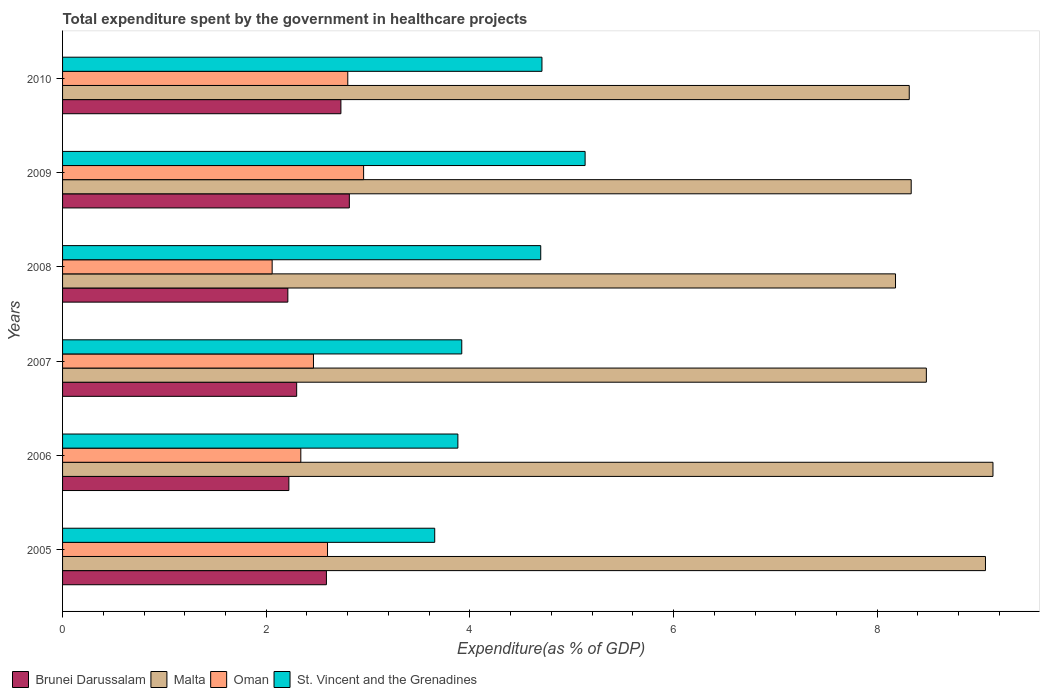Are the number of bars per tick equal to the number of legend labels?
Make the answer very short. Yes. How many bars are there on the 1st tick from the top?
Provide a short and direct response. 4. How many bars are there on the 6th tick from the bottom?
Your response must be concise. 4. What is the label of the 5th group of bars from the top?
Your response must be concise. 2006. In how many cases, is the number of bars for a given year not equal to the number of legend labels?
Your answer should be very brief. 0. What is the total expenditure spent by the government in healthcare projects in Brunei Darussalam in 2005?
Offer a terse response. 2.59. Across all years, what is the maximum total expenditure spent by the government in healthcare projects in St. Vincent and the Grenadines?
Offer a very short reply. 5.13. Across all years, what is the minimum total expenditure spent by the government in healthcare projects in Brunei Darussalam?
Ensure brevity in your answer.  2.21. In which year was the total expenditure spent by the government in healthcare projects in Oman maximum?
Offer a very short reply. 2009. In which year was the total expenditure spent by the government in healthcare projects in Oman minimum?
Your response must be concise. 2008. What is the total total expenditure spent by the government in healthcare projects in Brunei Darussalam in the graph?
Ensure brevity in your answer.  14.87. What is the difference between the total expenditure spent by the government in healthcare projects in St. Vincent and the Grenadines in 2005 and that in 2009?
Ensure brevity in your answer.  -1.48. What is the difference between the total expenditure spent by the government in healthcare projects in Oman in 2005 and the total expenditure spent by the government in healthcare projects in Brunei Darussalam in 2008?
Your response must be concise. 0.39. What is the average total expenditure spent by the government in healthcare projects in St. Vincent and the Grenadines per year?
Offer a terse response. 4.33. In the year 2006, what is the difference between the total expenditure spent by the government in healthcare projects in Malta and total expenditure spent by the government in healthcare projects in St. Vincent and the Grenadines?
Keep it short and to the point. 5.25. In how many years, is the total expenditure spent by the government in healthcare projects in Oman greater than 6.8 %?
Provide a succinct answer. 0. What is the ratio of the total expenditure spent by the government in healthcare projects in Oman in 2005 to that in 2008?
Provide a succinct answer. 1.26. What is the difference between the highest and the second highest total expenditure spent by the government in healthcare projects in Malta?
Provide a short and direct response. 0.07. What is the difference between the highest and the lowest total expenditure spent by the government in healthcare projects in Malta?
Your response must be concise. 0.96. Is it the case that in every year, the sum of the total expenditure spent by the government in healthcare projects in Malta and total expenditure spent by the government in healthcare projects in St. Vincent and the Grenadines is greater than the sum of total expenditure spent by the government in healthcare projects in Oman and total expenditure spent by the government in healthcare projects in Brunei Darussalam?
Provide a succinct answer. Yes. What does the 3rd bar from the top in 2010 represents?
Provide a succinct answer. Malta. What does the 1st bar from the bottom in 2007 represents?
Offer a very short reply. Brunei Darussalam. Is it the case that in every year, the sum of the total expenditure spent by the government in healthcare projects in St. Vincent and the Grenadines and total expenditure spent by the government in healthcare projects in Oman is greater than the total expenditure spent by the government in healthcare projects in Brunei Darussalam?
Give a very brief answer. Yes. How many years are there in the graph?
Keep it short and to the point. 6. Are the values on the major ticks of X-axis written in scientific E-notation?
Your response must be concise. No. Does the graph contain grids?
Your answer should be compact. No. What is the title of the graph?
Provide a short and direct response. Total expenditure spent by the government in healthcare projects. Does "Macao" appear as one of the legend labels in the graph?
Offer a terse response. No. What is the label or title of the X-axis?
Offer a terse response. Expenditure(as % of GDP). What is the label or title of the Y-axis?
Your answer should be very brief. Years. What is the Expenditure(as % of GDP) in Brunei Darussalam in 2005?
Make the answer very short. 2.59. What is the Expenditure(as % of GDP) in Malta in 2005?
Your response must be concise. 9.06. What is the Expenditure(as % of GDP) in Oman in 2005?
Give a very brief answer. 2.6. What is the Expenditure(as % of GDP) of St. Vincent and the Grenadines in 2005?
Provide a succinct answer. 3.65. What is the Expenditure(as % of GDP) in Brunei Darussalam in 2006?
Keep it short and to the point. 2.22. What is the Expenditure(as % of GDP) in Malta in 2006?
Provide a short and direct response. 9.14. What is the Expenditure(as % of GDP) of Oman in 2006?
Your answer should be compact. 2.34. What is the Expenditure(as % of GDP) in St. Vincent and the Grenadines in 2006?
Offer a terse response. 3.88. What is the Expenditure(as % of GDP) in Brunei Darussalam in 2007?
Your answer should be compact. 2.3. What is the Expenditure(as % of GDP) of Malta in 2007?
Offer a very short reply. 8.48. What is the Expenditure(as % of GDP) of Oman in 2007?
Your answer should be compact. 2.46. What is the Expenditure(as % of GDP) of St. Vincent and the Grenadines in 2007?
Give a very brief answer. 3.92. What is the Expenditure(as % of GDP) of Brunei Darussalam in 2008?
Your answer should be very brief. 2.21. What is the Expenditure(as % of GDP) in Malta in 2008?
Your response must be concise. 8.18. What is the Expenditure(as % of GDP) in Oman in 2008?
Your answer should be very brief. 2.06. What is the Expenditure(as % of GDP) of St. Vincent and the Grenadines in 2008?
Provide a succinct answer. 4.7. What is the Expenditure(as % of GDP) in Brunei Darussalam in 2009?
Provide a succinct answer. 2.82. What is the Expenditure(as % of GDP) in Malta in 2009?
Make the answer very short. 8.33. What is the Expenditure(as % of GDP) of Oman in 2009?
Your answer should be very brief. 2.96. What is the Expenditure(as % of GDP) in St. Vincent and the Grenadines in 2009?
Provide a succinct answer. 5.13. What is the Expenditure(as % of GDP) in Brunei Darussalam in 2010?
Keep it short and to the point. 2.73. What is the Expenditure(as % of GDP) of Malta in 2010?
Offer a very short reply. 8.31. What is the Expenditure(as % of GDP) of Oman in 2010?
Your answer should be very brief. 2.8. What is the Expenditure(as % of GDP) in St. Vincent and the Grenadines in 2010?
Make the answer very short. 4.71. Across all years, what is the maximum Expenditure(as % of GDP) in Brunei Darussalam?
Offer a very short reply. 2.82. Across all years, what is the maximum Expenditure(as % of GDP) in Malta?
Make the answer very short. 9.14. Across all years, what is the maximum Expenditure(as % of GDP) in Oman?
Provide a short and direct response. 2.96. Across all years, what is the maximum Expenditure(as % of GDP) of St. Vincent and the Grenadines?
Provide a succinct answer. 5.13. Across all years, what is the minimum Expenditure(as % of GDP) in Brunei Darussalam?
Keep it short and to the point. 2.21. Across all years, what is the minimum Expenditure(as % of GDP) in Malta?
Your response must be concise. 8.18. Across all years, what is the minimum Expenditure(as % of GDP) in Oman?
Provide a succinct answer. 2.06. Across all years, what is the minimum Expenditure(as % of GDP) in St. Vincent and the Grenadines?
Offer a very short reply. 3.65. What is the total Expenditure(as % of GDP) of Brunei Darussalam in the graph?
Make the answer very short. 14.87. What is the total Expenditure(as % of GDP) in Malta in the graph?
Make the answer very short. 51.51. What is the total Expenditure(as % of GDP) in Oman in the graph?
Offer a terse response. 15.22. What is the total Expenditure(as % of GDP) of St. Vincent and the Grenadines in the graph?
Your response must be concise. 25.99. What is the difference between the Expenditure(as % of GDP) in Brunei Darussalam in 2005 and that in 2006?
Give a very brief answer. 0.37. What is the difference between the Expenditure(as % of GDP) of Malta in 2005 and that in 2006?
Ensure brevity in your answer.  -0.07. What is the difference between the Expenditure(as % of GDP) in Oman in 2005 and that in 2006?
Offer a terse response. 0.26. What is the difference between the Expenditure(as % of GDP) in St. Vincent and the Grenadines in 2005 and that in 2006?
Give a very brief answer. -0.23. What is the difference between the Expenditure(as % of GDP) in Brunei Darussalam in 2005 and that in 2007?
Provide a succinct answer. 0.29. What is the difference between the Expenditure(as % of GDP) of Malta in 2005 and that in 2007?
Offer a terse response. 0.58. What is the difference between the Expenditure(as % of GDP) in Oman in 2005 and that in 2007?
Keep it short and to the point. 0.14. What is the difference between the Expenditure(as % of GDP) of St. Vincent and the Grenadines in 2005 and that in 2007?
Provide a succinct answer. -0.27. What is the difference between the Expenditure(as % of GDP) in Brunei Darussalam in 2005 and that in 2008?
Ensure brevity in your answer.  0.38. What is the difference between the Expenditure(as % of GDP) in Malta in 2005 and that in 2008?
Provide a succinct answer. 0.88. What is the difference between the Expenditure(as % of GDP) of Oman in 2005 and that in 2008?
Ensure brevity in your answer.  0.54. What is the difference between the Expenditure(as % of GDP) of St. Vincent and the Grenadines in 2005 and that in 2008?
Provide a short and direct response. -1.04. What is the difference between the Expenditure(as % of GDP) of Brunei Darussalam in 2005 and that in 2009?
Make the answer very short. -0.23. What is the difference between the Expenditure(as % of GDP) of Malta in 2005 and that in 2009?
Offer a terse response. 0.73. What is the difference between the Expenditure(as % of GDP) of Oman in 2005 and that in 2009?
Offer a terse response. -0.35. What is the difference between the Expenditure(as % of GDP) in St. Vincent and the Grenadines in 2005 and that in 2009?
Provide a succinct answer. -1.48. What is the difference between the Expenditure(as % of GDP) of Brunei Darussalam in 2005 and that in 2010?
Offer a terse response. -0.14. What is the difference between the Expenditure(as % of GDP) in Malta in 2005 and that in 2010?
Offer a very short reply. 0.75. What is the difference between the Expenditure(as % of GDP) in Oman in 2005 and that in 2010?
Keep it short and to the point. -0.2. What is the difference between the Expenditure(as % of GDP) of St. Vincent and the Grenadines in 2005 and that in 2010?
Your answer should be very brief. -1.05. What is the difference between the Expenditure(as % of GDP) of Brunei Darussalam in 2006 and that in 2007?
Give a very brief answer. -0.08. What is the difference between the Expenditure(as % of GDP) in Malta in 2006 and that in 2007?
Your response must be concise. 0.65. What is the difference between the Expenditure(as % of GDP) in Oman in 2006 and that in 2007?
Offer a very short reply. -0.12. What is the difference between the Expenditure(as % of GDP) of St. Vincent and the Grenadines in 2006 and that in 2007?
Make the answer very short. -0.04. What is the difference between the Expenditure(as % of GDP) in Brunei Darussalam in 2006 and that in 2008?
Provide a short and direct response. 0.01. What is the difference between the Expenditure(as % of GDP) of Malta in 2006 and that in 2008?
Provide a short and direct response. 0.96. What is the difference between the Expenditure(as % of GDP) in Oman in 2006 and that in 2008?
Ensure brevity in your answer.  0.28. What is the difference between the Expenditure(as % of GDP) in St. Vincent and the Grenadines in 2006 and that in 2008?
Ensure brevity in your answer.  -0.81. What is the difference between the Expenditure(as % of GDP) in Brunei Darussalam in 2006 and that in 2009?
Make the answer very short. -0.59. What is the difference between the Expenditure(as % of GDP) of Malta in 2006 and that in 2009?
Offer a very short reply. 0.8. What is the difference between the Expenditure(as % of GDP) of Oman in 2006 and that in 2009?
Ensure brevity in your answer.  -0.62. What is the difference between the Expenditure(as % of GDP) of St. Vincent and the Grenadines in 2006 and that in 2009?
Your response must be concise. -1.25. What is the difference between the Expenditure(as % of GDP) in Brunei Darussalam in 2006 and that in 2010?
Provide a short and direct response. -0.51. What is the difference between the Expenditure(as % of GDP) in Malta in 2006 and that in 2010?
Your response must be concise. 0.82. What is the difference between the Expenditure(as % of GDP) of Oman in 2006 and that in 2010?
Offer a terse response. -0.46. What is the difference between the Expenditure(as % of GDP) in St. Vincent and the Grenadines in 2006 and that in 2010?
Give a very brief answer. -0.83. What is the difference between the Expenditure(as % of GDP) in Brunei Darussalam in 2007 and that in 2008?
Make the answer very short. 0.09. What is the difference between the Expenditure(as % of GDP) in Malta in 2007 and that in 2008?
Provide a short and direct response. 0.3. What is the difference between the Expenditure(as % of GDP) in Oman in 2007 and that in 2008?
Your response must be concise. 0.41. What is the difference between the Expenditure(as % of GDP) in St. Vincent and the Grenadines in 2007 and that in 2008?
Provide a succinct answer. -0.78. What is the difference between the Expenditure(as % of GDP) in Brunei Darussalam in 2007 and that in 2009?
Make the answer very short. -0.52. What is the difference between the Expenditure(as % of GDP) of Malta in 2007 and that in 2009?
Ensure brevity in your answer.  0.15. What is the difference between the Expenditure(as % of GDP) of Oman in 2007 and that in 2009?
Make the answer very short. -0.49. What is the difference between the Expenditure(as % of GDP) in St. Vincent and the Grenadines in 2007 and that in 2009?
Make the answer very short. -1.21. What is the difference between the Expenditure(as % of GDP) in Brunei Darussalam in 2007 and that in 2010?
Provide a short and direct response. -0.43. What is the difference between the Expenditure(as % of GDP) of Malta in 2007 and that in 2010?
Give a very brief answer. 0.17. What is the difference between the Expenditure(as % of GDP) in Oman in 2007 and that in 2010?
Offer a terse response. -0.34. What is the difference between the Expenditure(as % of GDP) of St. Vincent and the Grenadines in 2007 and that in 2010?
Your answer should be very brief. -0.79. What is the difference between the Expenditure(as % of GDP) of Brunei Darussalam in 2008 and that in 2009?
Keep it short and to the point. -0.6. What is the difference between the Expenditure(as % of GDP) in Malta in 2008 and that in 2009?
Offer a very short reply. -0.15. What is the difference between the Expenditure(as % of GDP) in Oman in 2008 and that in 2009?
Make the answer very short. -0.9. What is the difference between the Expenditure(as % of GDP) of St. Vincent and the Grenadines in 2008 and that in 2009?
Your answer should be compact. -0.44. What is the difference between the Expenditure(as % of GDP) of Brunei Darussalam in 2008 and that in 2010?
Offer a terse response. -0.52. What is the difference between the Expenditure(as % of GDP) in Malta in 2008 and that in 2010?
Offer a very short reply. -0.13. What is the difference between the Expenditure(as % of GDP) in Oman in 2008 and that in 2010?
Your answer should be compact. -0.74. What is the difference between the Expenditure(as % of GDP) of St. Vincent and the Grenadines in 2008 and that in 2010?
Offer a very short reply. -0.01. What is the difference between the Expenditure(as % of GDP) of Brunei Darussalam in 2009 and that in 2010?
Your answer should be compact. 0.08. What is the difference between the Expenditure(as % of GDP) in Malta in 2009 and that in 2010?
Give a very brief answer. 0.02. What is the difference between the Expenditure(as % of GDP) of Oman in 2009 and that in 2010?
Offer a very short reply. 0.16. What is the difference between the Expenditure(as % of GDP) in St. Vincent and the Grenadines in 2009 and that in 2010?
Make the answer very short. 0.42. What is the difference between the Expenditure(as % of GDP) in Brunei Darussalam in 2005 and the Expenditure(as % of GDP) in Malta in 2006?
Your answer should be very brief. -6.55. What is the difference between the Expenditure(as % of GDP) in Brunei Darussalam in 2005 and the Expenditure(as % of GDP) in Oman in 2006?
Keep it short and to the point. 0.25. What is the difference between the Expenditure(as % of GDP) in Brunei Darussalam in 2005 and the Expenditure(as % of GDP) in St. Vincent and the Grenadines in 2006?
Your response must be concise. -1.29. What is the difference between the Expenditure(as % of GDP) of Malta in 2005 and the Expenditure(as % of GDP) of Oman in 2006?
Provide a short and direct response. 6.72. What is the difference between the Expenditure(as % of GDP) of Malta in 2005 and the Expenditure(as % of GDP) of St. Vincent and the Grenadines in 2006?
Give a very brief answer. 5.18. What is the difference between the Expenditure(as % of GDP) of Oman in 2005 and the Expenditure(as % of GDP) of St. Vincent and the Grenadines in 2006?
Give a very brief answer. -1.28. What is the difference between the Expenditure(as % of GDP) in Brunei Darussalam in 2005 and the Expenditure(as % of GDP) in Malta in 2007?
Provide a short and direct response. -5.89. What is the difference between the Expenditure(as % of GDP) in Brunei Darussalam in 2005 and the Expenditure(as % of GDP) in Oman in 2007?
Ensure brevity in your answer.  0.13. What is the difference between the Expenditure(as % of GDP) of Brunei Darussalam in 2005 and the Expenditure(as % of GDP) of St. Vincent and the Grenadines in 2007?
Ensure brevity in your answer.  -1.33. What is the difference between the Expenditure(as % of GDP) of Malta in 2005 and the Expenditure(as % of GDP) of Oman in 2007?
Offer a very short reply. 6.6. What is the difference between the Expenditure(as % of GDP) of Malta in 2005 and the Expenditure(as % of GDP) of St. Vincent and the Grenadines in 2007?
Provide a short and direct response. 5.14. What is the difference between the Expenditure(as % of GDP) in Oman in 2005 and the Expenditure(as % of GDP) in St. Vincent and the Grenadines in 2007?
Ensure brevity in your answer.  -1.32. What is the difference between the Expenditure(as % of GDP) of Brunei Darussalam in 2005 and the Expenditure(as % of GDP) of Malta in 2008?
Provide a succinct answer. -5.59. What is the difference between the Expenditure(as % of GDP) in Brunei Darussalam in 2005 and the Expenditure(as % of GDP) in Oman in 2008?
Your answer should be compact. 0.53. What is the difference between the Expenditure(as % of GDP) of Brunei Darussalam in 2005 and the Expenditure(as % of GDP) of St. Vincent and the Grenadines in 2008?
Offer a terse response. -2.1. What is the difference between the Expenditure(as % of GDP) of Malta in 2005 and the Expenditure(as % of GDP) of Oman in 2008?
Give a very brief answer. 7. What is the difference between the Expenditure(as % of GDP) in Malta in 2005 and the Expenditure(as % of GDP) in St. Vincent and the Grenadines in 2008?
Keep it short and to the point. 4.37. What is the difference between the Expenditure(as % of GDP) in Oman in 2005 and the Expenditure(as % of GDP) in St. Vincent and the Grenadines in 2008?
Offer a terse response. -2.09. What is the difference between the Expenditure(as % of GDP) of Brunei Darussalam in 2005 and the Expenditure(as % of GDP) of Malta in 2009?
Your answer should be very brief. -5.74. What is the difference between the Expenditure(as % of GDP) in Brunei Darussalam in 2005 and the Expenditure(as % of GDP) in Oman in 2009?
Offer a terse response. -0.37. What is the difference between the Expenditure(as % of GDP) in Brunei Darussalam in 2005 and the Expenditure(as % of GDP) in St. Vincent and the Grenadines in 2009?
Keep it short and to the point. -2.54. What is the difference between the Expenditure(as % of GDP) in Malta in 2005 and the Expenditure(as % of GDP) in Oman in 2009?
Give a very brief answer. 6.11. What is the difference between the Expenditure(as % of GDP) of Malta in 2005 and the Expenditure(as % of GDP) of St. Vincent and the Grenadines in 2009?
Make the answer very short. 3.93. What is the difference between the Expenditure(as % of GDP) of Oman in 2005 and the Expenditure(as % of GDP) of St. Vincent and the Grenadines in 2009?
Offer a very short reply. -2.53. What is the difference between the Expenditure(as % of GDP) of Brunei Darussalam in 2005 and the Expenditure(as % of GDP) of Malta in 2010?
Keep it short and to the point. -5.72. What is the difference between the Expenditure(as % of GDP) of Brunei Darussalam in 2005 and the Expenditure(as % of GDP) of Oman in 2010?
Keep it short and to the point. -0.21. What is the difference between the Expenditure(as % of GDP) of Brunei Darussalam in 2005 and the Expenditure(as % of GDP) of St. Vincent and the Grenadines in 2010?
Your answer should be very brief. -2.12. What is the difference between the Expenditure(as % of GDP) of Malta in 2005 and the Expenditure(as % of GDP) of Oman in 2010?
Offer a very short reply. 6.26. What is the difference between the Expenditure(as % of GDP) in Malta in 2005 and the Expenditure(as % of GDP) in St. Vincent and the Grenadines in 2010?
Provide a short and direct response. 4.36. What is the difference between the Expenditure(as % of GDP) of Oman in 2005 and the Expenditure(as % of GDP) of St. Vincent and the Grenadines in 2010?
Provide a succinct answer. -2.11. What is the difference between the Expenditure(as % of GDP) of Brunei Darussalam in 2006 and the Expenditure(as % of GDP) of Malta in 2007?
Offer a terse response. -6.26. What is the difference between the Expenditure(as % of GDP) of Brunei Darussalam in 2006 and the Expenditure(as % of GDP) of Oman in 2007?
Offer a terse response. -0.24. What is the difference between the Expenditure(as % of GDP) in Brunei Darussalam in 2006 and the Expenditure(as % of GDP) in St. Vincent and the Grenadines in 2007?
Provide a short and direct response. -1.7. What is the difference between the Expenditure(as % of GDP) in Malta in 2006 and the Expenditure(as % of GDP) in Oman in 2007?
Provide a short and direct response. 6.67. What is the difference between the Expenditure(as % of GDP) of Malta in 2006 and the Expenditure(as % of GDP) of St. Vincent and the Grenadines in 2007?
Offer a terse response. 5.22. What is the difference between the Expenditure(as % of GDP) of Oman in 2006 and the Expenditure(as % of GDP) of St. Vincent and the Grenadines in 2007?
Keep it short and to the point. -1.58. What is the difference between the Expenditure(as % of GDP) in Brunei Darussalam in 2006 and the Expenditure(as % of GDP) in Malta in 2008?
Give a very brief answer. -5.96. What is the difference between the Expenditure(as % of GDP) in Brunei Darussalam in 2006 and the Expenditure(as % of GDP) in Oman in 2008?
Your answer should be very brief. 0.16. What is the difference between the Expenditure(as % of GDP) in Brunei Darussalam in 2006 and the Expenditure(as % of GDP) in St. Vincent and the Grenadines in 2008?
Ensure brevity in your answer.  -2.47. What is the difference between the Expenditure(as % of GDP) in Malta in 2006 and the Expenditure(as % of GDP) in Oman in 2008?
Offer a very short reply. 7.08. What is the difference between the Expenditure(as % of GDP) in Malta in 2006 and the Expenditure(as % of GDP) in St. Vincent and the Grenadines in 2008?
Provide a succinct answer. 4.44. What is the difference between the Expenditure(as % of GDP) of Oman in 2006 and the Expenditure(as % of GDP) of St. Vincent and the Grenadines in 2008?
Make the answer very short. -2.36. What is the difference between the Expenditure(as % of GDP) of Brunei Darussalam in 2006 and the Expenditure(as % of GDP) of Malta in 2009?
Give a very brief answer. -6.11. What is the difference between the Expenditure(as % of GDP) in Brunei Darussalam in 2006 and the Expenditure(as % of GDP) in Oman in 2009?
Your response must be concise. -0.73. What is the difference between the Expenditure(as % of GDP) of Brunei Darussalam in 2006 and the Expenditure(as % of GDP) of St. Vincent and the Grenadines in 2009?
Your response must be concise. -2.91. What is the difference between the Expenditure(as % of GDP) in Malta in 2006 and the Expenditure(as % of GDP) in Oman in 2009?
Offer a terse response. 6.18. What is the difference between the Expenditure(as % of GDP) of Malta in 2006 and the Expenditure(as % of GDP) of St. Vincent and the Grenadines in 2009?
Keep it short and to the point. 4. What is the difference between the Expenditure(as % of GDP) of Oman in 2006 and the Expenditure(as % of GDP) of St. Vincent and the Grenadines in 2009?
Your response must be concise. -2.79. What is the difference between the Expenditure(as % of GDP) of Brunei Darussalam in 2006 and the Expenditure(as % of GDP) of Malta in 2010?
Provide a short and direct response. -6.09. What is the difference between the Expenditure(as % of GDP) of Brunei Darussalam in 2006 and the Expenditure(as % of GDP) of Oman in 2010?
Offer a terse response. -0.58. What is the difference between the Expenditure(as % of GDP) in Brunei Darussalam in 2006 and the Expenditure(as % of GDP) in St. Vincent and the Grenadines in 2010?
Your answer should be compact. -2.49. What is the difference between the Expenditure(as % of GDP) in Malta in 2006 and the Expenditure(as % of GDP) in Oman in 2010?
Give a very brief answer. 6.34. What is the difference between the Expenditure(as % of GDP) in Malta in 2006 and the Expenditure(as % of GDP) in St. Vincent and the Grenadines in 2010?
Your answer should be very brief. 4.43. What is the difference between the Expenditure(as % of GDP) of Oman in 2006 and the Expenditure(as % of GDP) of St. Vincent and the Grenadines in 2010?
Offer a very short reply. -2.37. What is the difference between the Expenditure(as % of GDP) of Brunei Darussalam in 2007 and the Expenditure(as % of GDP) of Malta in 2008?
Offer a very short reply. -5.88. What is the difference between the Expenditure(as % of GDP) of Brunei Darussalam in 2007 and the Expenditure(as % of GDP) of Oman in 2008?
Keep it short and to the point. 0.24. What is the difference between the Expenditure(as % of GDP) in Brunei Darussalam in 2007 and the Expenditure(as % of GDP) in St. Vincent and the Grenadines in 2008?
Offer a terse response. -2.4. What is the difference between the Expenditure(as % of GDP) in Malta in 2007 and the Expenditure(as % of GDP) in Oman in 2008?
Offer a terse response. 6.42. What is the difference between the Expenditure(as % of GDP) of Malta in 2007 and the Expenditure(as % of GDP) of St. Vincent and the Grenadines in 2008?
Your answer should be compact. 3.79. What is the difference between the Expenditure(as % of GDP) in Oman in 2007 and the Expenditure(as % of GDP) in St. Vincent and the Grenadines in 2008?
Provide a short and direct response. -2.23. What is the difference between the Expenditure(as % of GDP) of Brunei Darussalam in 2007 and the Expenditure(as % of GDP) of Malta in 2009?
Offer a very short reply. -6.03. What is the difference between the Expenditure(as % of GDP) of Brunei Darussalam in 2007 and the Expenditure(as % of GDP) of Oman in 2009?
Offer a very short reply. -0.66. What is the difference between the Expenditure(as % of GDP) in Brunei Darussalam in 2007 and the Expenditure(as % of GDP) in St. Vincent and the Grenadines in 2009?
Keep it short and to the point. -2.83. What is the difference between the Expenditure(as % of GDP) of Malta in 2007 and the Expenditure(as % of GDP) of Oman in 2009?
Provide a succinct answer. 5.53. What is the difference between the Expenditure(as % of GDP) of Malta in 2007 and the Expenditure(as % of GDP) of St. Vincent and the Grenadines in 2009?
Your answer should be compact. 3.35. What is the difference between the Expenditure(as % of GDP) of Oman in 2007 and the Expenditure(as % of GDP) of St. Vincent and the Grenadines in 2009?
Your answer should be compact. -2.67. What is the difference between the Expenditure(as % of GDP) of Brunei Darussalam in 2007 and the Expenditure(as % of GDP) of Malta in 2010?
Offer a terse response. -6.02. What is the difference between the Expenditure(as % of GDP) of Brunei Darussalam in 2007 and the Expenditure(as % of GDP) of Oman in 2010?
Your response must be concise. -0.5. What is the difference between the Expenditure(as % of GDP) in Brunei Darussalam in 2007 and the Expenditure(as % of GDP) in St. Vincent and the Grenadines in 2010?
Provide a short and direct response. -2.41. What is the difference between the Expenditure(as % of GDP) of Malta in 2007 and the Expenditure(as % of GDP) of Oman in 2010?
Ensure brevity in your answer.  5.68. What is the difference between the Expenditure(as % of GDP) of Malta in 2007 and the Expenditure(as % of GDP) of St. Vincent and the Grenadines in 2010?
Make the answer very short. 3.77. What is the difference between the Expenditure(as % of GDP) of Oman in 2007 and the Expenditure(as % of GDP) of St. Vincent and the Grenadines in 2010?
Your answer should be compact. -2.24. What is the difference between the Expenditure(as % of GDP) of Brunei Darussalam in 2008 and the Expenditure(as % of GDP) of Malta in 2009?
Make the answer very short. -6.12. What is the difference between the Expenditure(as % of GDP) of Brunei Darussalam in 2008 and the Expenditure(as % of GDP) of Oman in 2009?
Ensure brevity in your answer.  -0.74. What is the difference between the Expenditure(as % of GDP) of Brunei Darussalam in 2008 and the Expenditure(as % of GDP) of St. Vincent and the Grenadines in 2009?
Give a very brief answer. -2.92. What is the difference between the Expenditure(as % of GDP) in Malta in 2008 and the Expenditure(as % of GDP) in Oman in 2009?
Provide a succinct answer. 5.22. What is the difference between the Expenditure(as % of GDP) of Malta in 2008 and the Expenditure(as % of GDP) of St. Vincent and the Grenadines in 2009?
Keep it short and to the point. 3.05. What is the difference between the Expenditure(as % of GDP) of Oman in 2008 and the Expenditure(as % of GDP) of St. Vincent and the Grenadines in 2009?
Ensure brevity in your answer.  -3.07. What is the difference between the Expenditure(as % of GDP) of Brunei Darussalam in 2008 and the Expenditure(as % of GDP) of Malta in 2010?
Give a very brief answer. -6.1. What is the difference between the Expenditure(as % of GDP) of Brunei Darussalam in 2008 and the Expenditure(as % of GDP) of Oman in 2010?
Make the answer very short. -0.59. What is the difference between the Expenditure(as % of GDP) in Brunei Darussalam in 2008 and the Expenditure(as % of GDP) in St. Vincent and the Grenadines in 2010?
Offer a terse response. -2.5. What is the difference between the Expenditure(as % of GDP) of Malta in 2008 and the Expenditure(as % of GDP) of Oman in 2010?
Provide a succinct answer. 5.38. What is the difference between the Expenditure(as % of GDP) in Malta in 2008 and the Expenditure(as % of GDP) in St. Vincent and the Grenadines in 2010?
Give a very brief answer. 3.47. What is the difference between the Expenditure(as % of GDP) of Oman in 2008 and the Expenditure(as % of GDP) of St. Vincent and the Grenadines in 2010?
Provide a succinct answer. -2.65. What is the difference between the Expenditure(as % of GDP) of Brunei Darussalam in 2009 and the Expenditure(as % of GDP) of Malta in 2010?
Keep it short and to the point. -5.5. What is the difference between the Expenditure(as % of GDP) in Brunei Darussalam in 2009 and the Expenditure(as % of GDP) in Oman in 2010?
Your answer should be compact. 0.02. What is the difference between the Expenditure(as % of GDP) in Brunei Darussalam in 2009 and the Expenditure(as % of GDP) in St. Vincent and the Grenadines in 2010?
Provide a short and direct response. -1.89. What is the difference between the Expenditure(as % of GDP) of Malta in 2009 and the Expenditure(as % of GDP) of Oman in 2010?
Offer a very short reply. 5.53. What is the difference between the Expenditure(as % of GDP) of Malta in 2009 and the Expenditure(as % of GDP) of St. Vincent and the Grenadines in 2010?
Your response must be concise. 3.63. What is the difference between the Expenditure(as % of GDP) of Oman in 2009 and the Expenditure(as % of GDP) of St. Vincent and the Grenadines in 2010?
Your answer should be compact. -1.75. What is the average Expenditure(as % of GDP) in Brunei Darussalam per year?
Provide a succinct answer. 2.48. What is the average Expenditure(as % of GDP) of Malta per year?
Offer a terse response. 8.58. What is the average Expenditure(as % of GDP) in Oman per year?
Give a very brief answer. 2.54. What is the average Expenditure(as % of GDP) in St. Vincent and the Grenadines per year?
Your answer should be compact. 4.33. In the year 2005, what is the difference between the Expenditure(as % of GDP) in Brunei Darussalam and Expenditure(as % of GDP) in Malta?
Provide a short and direct response. -6.47. In the year 2005, what is the difference between the Expenditure(as % of GDP) in Brunei Darussalam and Expenditure(as % of GDP) in Oman?
Make the answer very short. -0.01. In the year 2005, what is the difference between the Expenditure(as % of GDP) of Brunei Darussalam and Expenditure(as % of GDP) of St. Vincent and the Grenadines?
Your answer should be compact. -1.06. In the year 2005, what is the difference between the Expenditure(as % of GDP) of Malta and Expenditure(as % of GDP) of Oman?
Offer a very short reply. 6.46. In the year 2005, what is the difference between the Expenditure(as % of GDP) in Malta and Expenditure(as % of GDP) in St. Vincent and the Grenadines?
Give a very brief answer. 5.41. In the year 2005, what is the difference between the Expenditure(as % of GDP) in Oman and Expenditure(as % of GDP) in St. Vincent and the Grenadines?
Provide a succinct answer. -1.05. In the year 2006, what is the difference between the Expenditure(as % of GDP) in Brunei Darussalam and Expenditure(as % of GDP) in Malta?
Your answer should be very brief. -6.91. In the year 2006, what is the difference between the Expenditure(as % of GDP) of Brunei Darussalam and Expenditure(as % of GDP) of Oman?
Provide a succinct answer. -0.12. In the year 2006, what is the difference between the Expenditure(as % of GDP) of Brunei Darussalam and Expenditure(as % of GDP) of St. Vincent and the Grenadines?
Offer a terse response. -1.66. In the year 2006, what is the difference between the Expenditure(as % of GDP) of Malta and Expenditure(as % of GDP) of Oman?
Provide a short and direct response. 6.8. In the year 2006, what is the difference between the Expenditure(as % of GDP) in Malta and Expenditure(as % of GDP) in St. Vincent and the Grenadines?
Provide a succinct answer. 5.25. In the year 2006, what is the difference between the Expenditure(as % of GDP) in Oman and Expenditure(as % of GDP) in St. Vincent and the Grenadines?
Give a very brief answer. -1.54. In the year 2007, what is the difference between the Expenditure(as % of GDP) of Brunei Darussalam and Expenditure(as % of GDP) of Malta?
Your answer should be compact. -6.18. In the year 2007, what is the difference between the Expenditure(as % of GDP) in Brunei Darussalam and Expenditure(as % of GDP) in Oman?
Ensure brevity in your answer.  -0.16. In the year 2007, what is the difference between the Expenditure(as % of GDP) in Brunei Darussalam and Expenditure(as % of GDP) in St. Vincent and the Grenadines?
Offer a terse response. -1.62. In the year 2007, what is the difference between the Expenditure(as % of GDP) of Malta and Expenditure(as % of GDP) of Oman?
Your answer should be compact. 6.02. In the year 2007, what is the difference between the Expenditure(as % of GDP) of Malta and Expenditure(as % of GDP) of St. Vincent and the Grenadines?
Provide a succinct answer. 4.56. In the year 2007, what is the difference between the Expenditure(as % of GDP) of Oman and Expenditure(as % of GDP) of St. Vincent and the Grenadines?
Give a very brief answer. -1.46. In the year 2008, what is the difference between the Expenditure(as % of GDP) of Brunei Darussalam and Expenditure(as % of GDP) of Malta?
Give a very brief answer. -5.97. In the year 2008, what is the difference between the Expenditure(as % of GDP) in Brunei Darussalam and Expenditure(as % of GDP) in Oman?
Your answer should be compact. 0.15. In the year 2008, what is the difference between the Expenditure(as % of GDP) of Brunei Darussalam and Expenditure(as % of GDP) of St. Vincent and the Grenadines?
Provide a short and direct response. -2.48. In the year 2008, what is the difference between the Expenditure(as % of GDP) of Malta and Expenditure(as % of GDP) of Oman?
Your answer should be compact. 6.12. In the year 2008, what is the difference between the Expenditure(as % of GDP) in Malta and Expenditure(as % of GDP) in St. Vincent and the Grenadines?
Your response must be concise. 3.48. In the year 2008, what is the difference between the Expenditure(as % of GDP) in Oman and Expenditure(as % of GDP) in St. Vincent and the Grenadines?
Give a very brief answer. -2.64. In the year 2009, what is the difference between the Expenditure(as % of GDP) of Brunei Darussalam and Expenditure(as % of GDP) of Malta?
Your answer should be very brief. -5.52. In the year 2009, what is the difference between the Expenditure(as % of GDP) in Brunei Darussalam and Expenditure(as % of GDP) in Oman?
Provide a short and direct response. -0.14. In the year 2009, what is the difference between the Expenditure(as % of GDP) of Brunei Darussalam and Expenditure(as % of GDP) of St. Vincent and the Grenadines?
Make the answer very short. -2.32. In the year 2009, what is the difference between the Expenditure(as % of GDP) in Malta and Expenditure(as % of GDP) in Oman?
Keep it short and to the point. 5.38. In the year 2009, what is the difference between the Expenditure(as % of GDP) of Malta and Expenditure(as % of GDP) of St. Vincent and the Grenadines?
Provide a succinct answer. 3.2. In the year 2009, what is the difference between the Expenditure(as % of GDP) of Oman and Expenditure(as % of GDP) of St. Vincent and the Grenadines?
Provide a succinct answer. -2.18. In the year 2010, what is the difference between the Expenditure(as % of GDP) in Brunei Darussalam and Expenditure(as % of GDP) in Malta?
Offer a terse response. -5.58. In the year 2010, what is the difference between the Expenditure(as % of GDP) in Brunei Darussalam and Expenditure(as % of GDP) in Oman?
Provide a succinct answer. -0.07. In the year 2010, what is the difference between the Expenditure(as % of GDP) of Brunei Darussalam and Expenditure(as % of GDP) of St. Vincent and the Grenadines?
Offer a very short reply. -1.97. In the year 2010, what is the difference between the Expenditure(as % of GDP) of Malta and Expenditure(as % of GDP) of Oman?
Offer a terse response. 5.51. In the year 2010, what is the difference between the Expenditure(as % of GDP) in Malta and Expenditure(as % of GDP) in St. Vincent and the Grenadines?
Provide a succinct answer. 3.61. In the year 2010, what is the difference between the Expenditure(as % of GDP) of Oman and Expenditure(as % of GDP) of St. Vincent and the Grenadines?
Ensure brevity in your answer.  -1.91. What is the ratio of the Expenditure(as % of GDP) in Brunei Darussalam in 2005 to that in 2006?
Keep it short and to the point. 1.17. What is the ratio of the Expenditure(as % of GDP) in Oman in 2005 to that in 2006?
Provide a succinct answer. 1.11. What is the ratio of the Expenditure(as % of GDP) of St. Vincent and the Grenadines in 2005 to that in 2006?
Provide a succinct answer. 0.94. What is the ratio of the Expenditure(as % of GDP) in Brunei Darussalam in 2005 to that in 2007?
Keep it short and to the point. 1.13. What is the ratio of the Expenditure(as % of GDP) in Malta in 2005 to that in 2007?
Give a very brief answer. 1.07. What is the ratio of the Expenditure(as % of GDP) in Oman in 2005 to that in 2007?
Keep it short and to the point. 1.06. What is the ratio of the Expenditure(as % of GDP) in St. Vincent and the Grenadines in 2005 to that in 2007?
Offer a terse response. 0.93. What is the ratio of the Expenditure(as % of GDP) of Brunei Darussalam in 2005 to that in 2008?
Offer a terse response. 1.17. What is the ratio of the Expenditure(as % of GDP) of Malta in 2005 to that in 2008?
Your answer should be very brief. 1.11. What is the ratio of the Expenditure(as % of GDP) of Oman in 2005 to that in 2008?
Ensure brevity in your answer.  1.26. What is the ratio of the Expenditure(as % of GDP) in St. Vincent and the Grenadines in 2005 to that in 2008?
Provide a succinct answer. 0.78. What is the ratio of the Expenditure(as % of GDP) in Brunei Darussalam in 2005 to that in 2009?
Your answer should be compact. 0.92. What is the ratio of the Expenditure(as % of GDP) of Malta in 2005 to that in 2009?
Make the answer very short. 1.09. What is the ratio of the Expenditure(as % of GDP) in Oman in 2005 to that in 2009?
Ensure brevity in your answer.  0.88. What is the ratio of the Expenditure(as % of GDP) in St. Vincent and the Grenadines in 2005 to that in 2009?
Keep it short and to the point. 0.71. What is the ratio of the Expenditure(as % of GDP) of Brunei Darussalam in 2005 to that in 2010?
Keep it short and to the point. 0.95. What is the ratio of the Expenditure(as % of GDP) of Malta in 2005 to that in 2010?
Keep it short and to the point. 1.09. What is the ratio of the Expenditure(as % of GDP) in Oman in 2005 to that in 2010?
Provide a succinct answer. 0.93. What is the ratio of the Expenditure(as % of GDP) in St. Vincent and the Grenadines in 2005 to that in 2010?
Provide a short and direct response. 0.78. What is the ratio of the Expenditure(as % of GDP) in Brunei Darussalam in 2006 to that in 2007?
Offer a very short reply. 0.97. What is the ratio of the Expenditure(as % of GDP) in Malta in 2006 to that in 2007?
Your answer should be very brief. 1.08. What is the ratio of the Expenditure(as % of GDP) of Oman in 2006 to that in 2007?
Give a very brief answer. 0.95. What is the ratio of the Expenditure(as % of GDP) of St. Vincent and the Grenadines in 2006 to that in 2007?
Provide a succinct answer. 0.99. What is the ratio of the Expenditure(as % of GDP) of Malta in 2006 to that in 2008?
Give a very brief answer. 1.12. What is the ratio of the Expenditure(as % of GDP) of Oman in 2006 to that in 2008?
Provide a short and direct response. 1.14. What is the ratio of the Expenditure(as % of GDP) in St. Vincent and the Grenadines in 2006 to that in 2008?
Make the answer very short. 0.83. What is the ratio of the Expenditure(as % of GDP) in Brunei Darussalam in 2006 to that in 2009?
Your response must be concise. 0.79. What is the ratio of the Expenditure(as % of GDP) of Malta in 2006 to that in 2009?
Provide a succinct answer. 1.1. What is the ratio of the Expenditure(as % of GDP) in Oman in 2006 to that in 2009?
Offer a very short reply. 0.79. What is the ratio of the Expenditure(as % of GDP) in St. Vincent and the Grenadines in 2006 to that in 2009?
Your response must be concise. 0.76. What is the ratio of the Expenditure(as % of GDP) of Brunei Darussalam in 2006 to that in 2010?
Provide a short and direct response. 0.81. What is the ratio of the Expenditure(as % of GDP) in Malta in 2006 to that in 2010?
Offer a terse response. 1.1. What is the ratio of the Expenditure(as % of GDP) of Oman in 2006 to that in 2010?
Your answer should be very brief. 0.84. What is the ratio of the Expenditure(as % of GDP) in St. Vincent and the Grenadines in 2006 to that in 2010?
Offer a terse response. 0.82. What is the ratio of the Expenditure(as % of GDP) in Brunei Darussalam in 2007 to that in 2008?
Provide a short and direct response. 1.04. What is the ratio of the Expenditure(as % of GDP) in Malta in 2007 to that in 2008?
Make the answer very short. 1.04. What is the ratio of the Expenditure(as % of GDP) in Oman in 2007 to that in 2008?
Make the answer very short. 1.2. What is the ratio of the Expenditure(as % of GDP) in St. Vincent and the Grenadines in 2007 to that in 2008?
Provide a short and direct response. 0.83. What is the ratio of the Expenditure(as % of GDP) in Brunei Darussalam in 2007 to that in 2009?
Provide a short and direct response. 0.82. What is the ratio of the Expenditure(as % of GDP) of Malta in 2007 to that in 2009?
Give a very brief answer. 1.02. What is the ratio of the Expenditure(as % of GDP) in Oman in 2007 to that in 2009?
Provide a succinct answer. 0.83. What is the ratio of the Expenditure(as % of GDP) of St. Vincent and the Grenadines in 2007 to that in 2009?
Your response must be concise. 0.76. What is the ratio of the Expenditure(as % of GDP) of Brunei Darussalam in 2007 to that in 2010?
Your answer should be compact. 0.84. What is the ratio of the Expenditure(as % of GDP) of Malta in 2007 to that in 2010?
Offer a very short reply. 1.02. What is the ratio of the Expenditure(as % of GDP) in Oman in 2007 to that in 2010?
Your response must be concise. 0.88. What is the ratio of the Expenditure(as % of GDP) in St. Vincent and the Grenadines in 2007 to that in 2010?
Keep it short and to the point. 0.83. What is the ratio of the Expenditure(as % of GDP) of Brunei Darussalam in 2008 to that in 2009?
Provide a short and direct response. 0.79. What is the ratio of the Expenditure(as % of GDP) in Malta in 2008 to that in 2009?
Make the answer very short. 0.98. What is the ratio of the Expenditure(as % of GDP) of Oman in 2008 to that in 2009?
Provide a short and direct response. 0.7. What is the ratio of the Expenditure(as % of GDP) in St. Vincent and the Grenadines in 2008 to that in 2009?
Your answer should be very brief. 0.92. What is the ratio of the Expenditure(as % of GDP) of Brunei Darussalam in 2008 to that in 2010?
Offer a terse response. 0.81. What is the ratio of the Expenditure(as % of GDP) of Malta in 2008 to that in 2010?
Ensure brevity in your answer.  0.98. What is the ratio of the Expenditure(as % of GDP) of Oman in 2008 to that in 2010?
Give a very brief answer. 0.73. What is the ratio of the Expenditure(as % of GDP) of Brunei Darussalam in 2009 to that in 2010?
Ensure brevity in your answer.  1.03. What is the ratio of the Expenditure(as % of GDP) in Oman in 2009 to that in 2010?
Ensure brevity in your answer.  1.06. What is the ratio of the Expenditure(as % of GDP) of St. Vincent and the Grenadines in 2009 to that in 2010?
Provide a short and direct response. 1.09. What is the difference between the highest and the second highest Expenditure(as % of GDP) in Brunei Darussalam?
Make the answer very short. 0.08. What is the difference between the highest and the second highest Expenditure(as % of GDP) of Malta?
Your response must be concise. 0.07. What is the difference between the highest and the second highest Expenditure(as % of GDP) in Oman?
Offer a terse response. 0.16. What is the difference between the highest and the second highest Expenditure(as % of GDP) in St. Vincent and the Grenadines?
Provide a succinct answer. 0.42. What is the difference between the highest and the lowest Expenditure(as % of GDP) of Brunei Darussalam?
Offer a very short reply. 0.6. What is the difference between the highest and the lowest Expenditure(as % of GDP) of Malta?
Your response must be concise. 0.96. What is the difference between the highest and the lowest Expenditure(as % of GDP) in Oman?
Your answer should be compact. 0.9. What is the difference between the highest and the lowest Expenditure(as % of GDP) in St. Vincent and the Grenadines?
Make the answer very short. 1.48. 